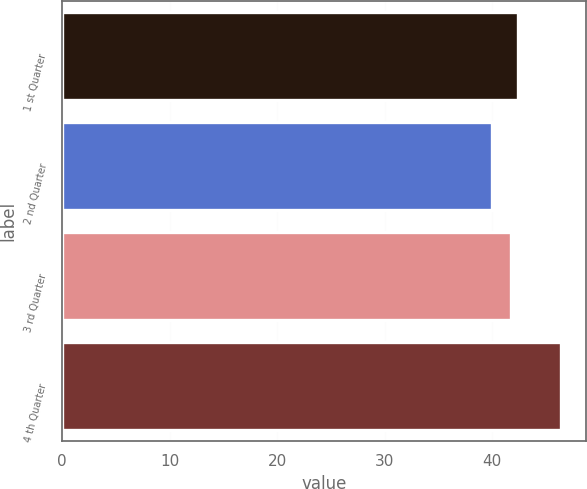Convert chart to OTSL. <chart><loc_0><loc_0><loc_500><loc_500><bar_chart><fcel>1 st Quarter<fcel>2 nd Quarter<fcel>3 rd Quarter<fcel>4 th Quarter<nl><fcel>42.41<fcel>40<fcel>41.77<fcel>46.35<nl></chart> 